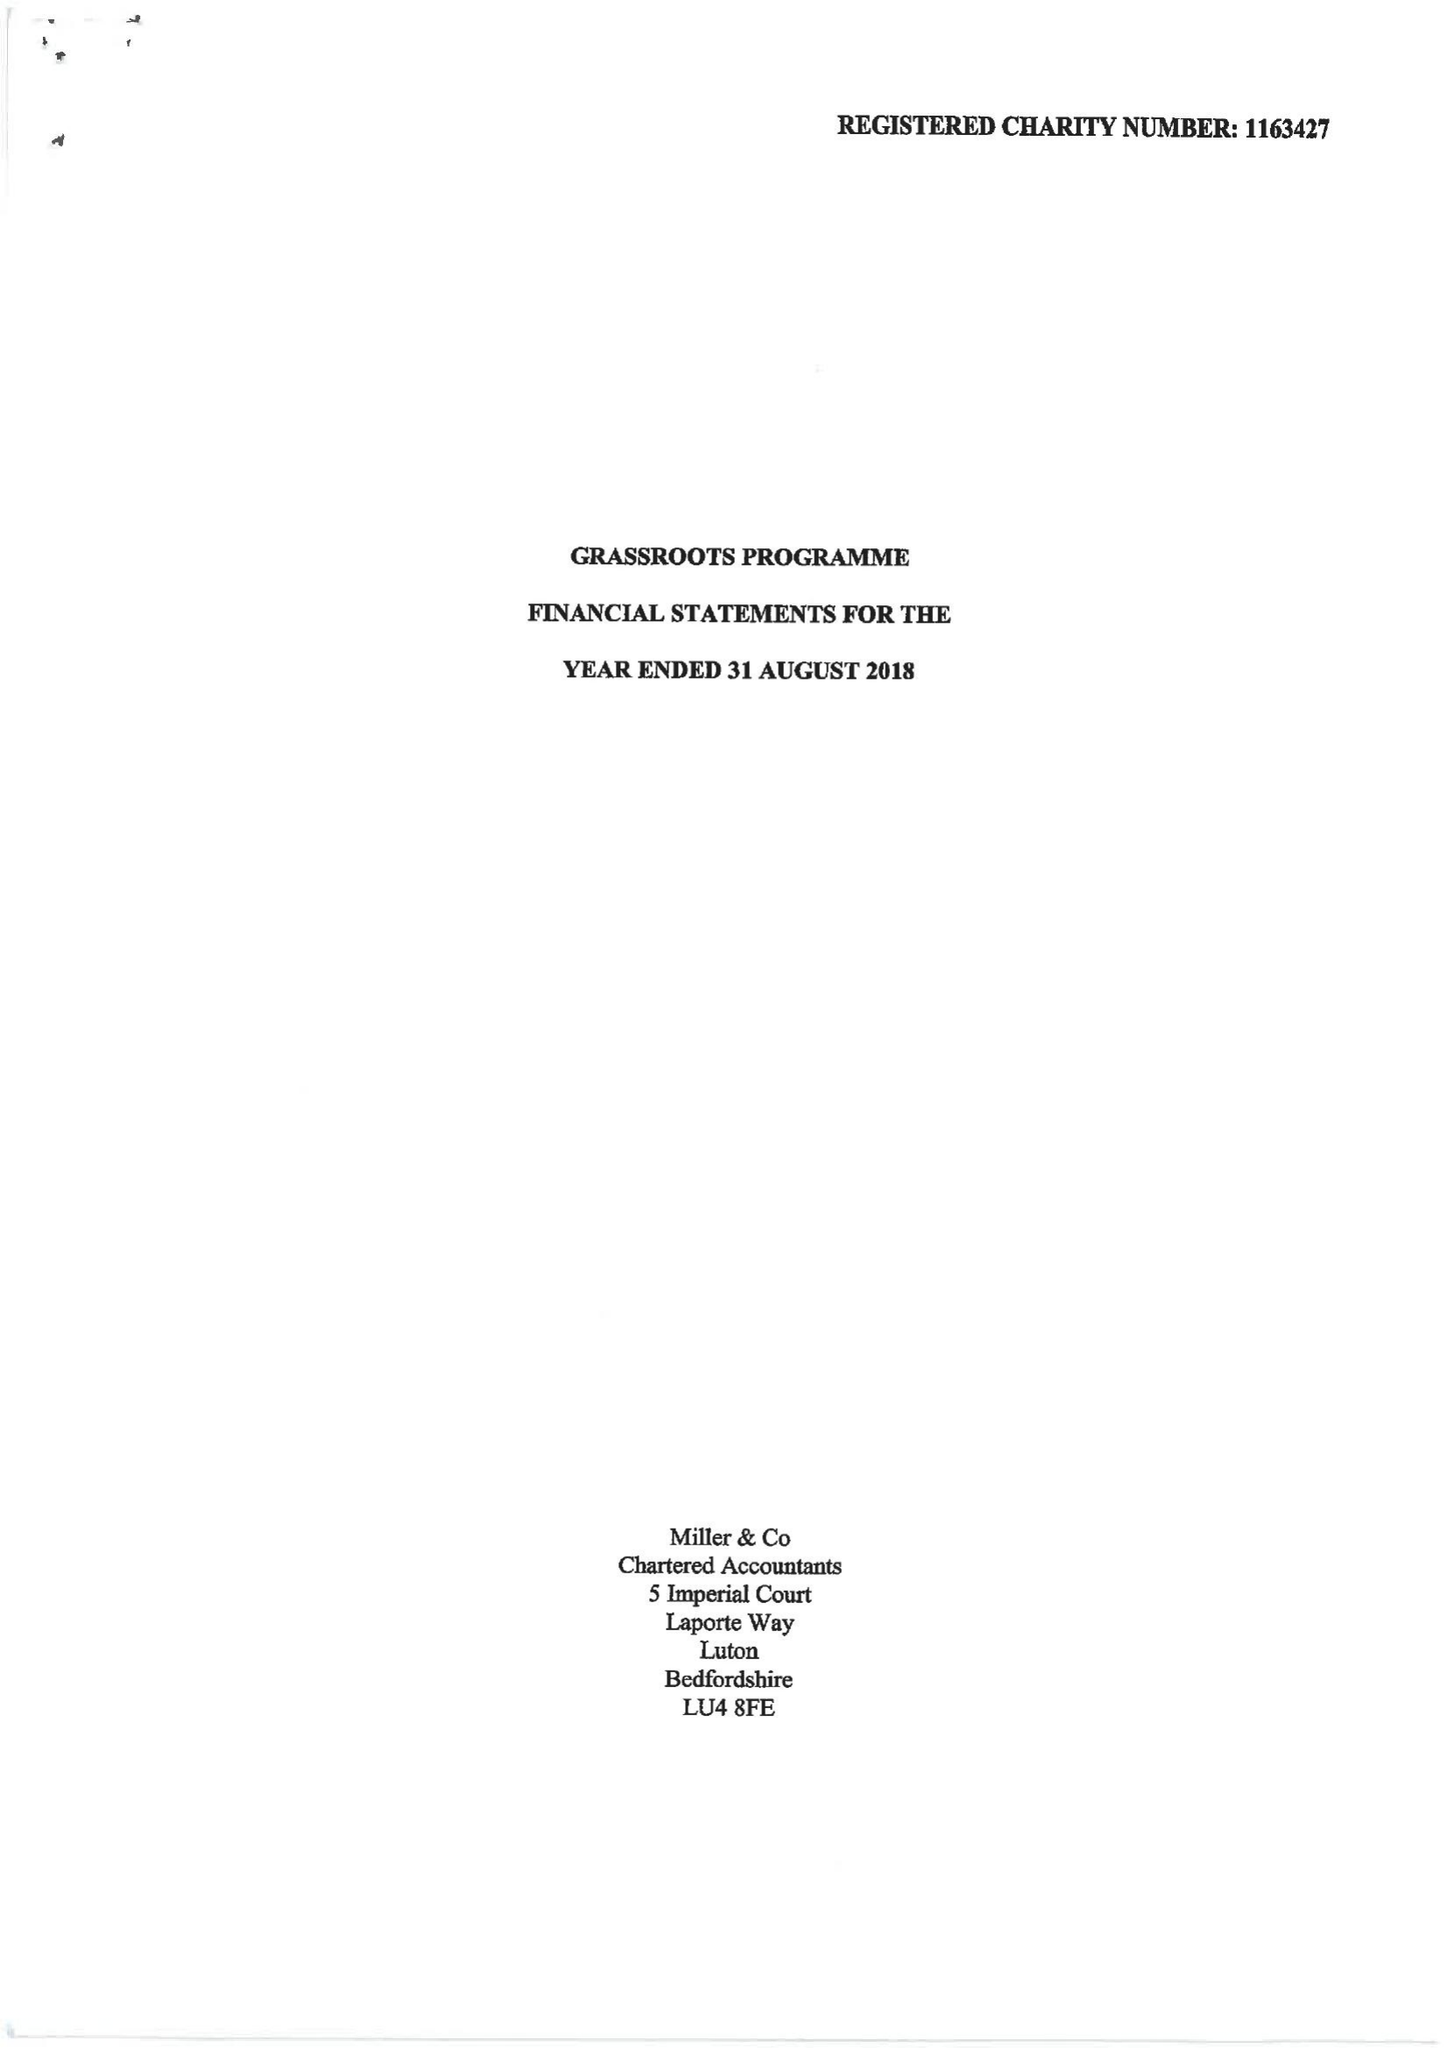What is the value for the address__post_town?
Answer the question using a single word or phrase. LUTON 